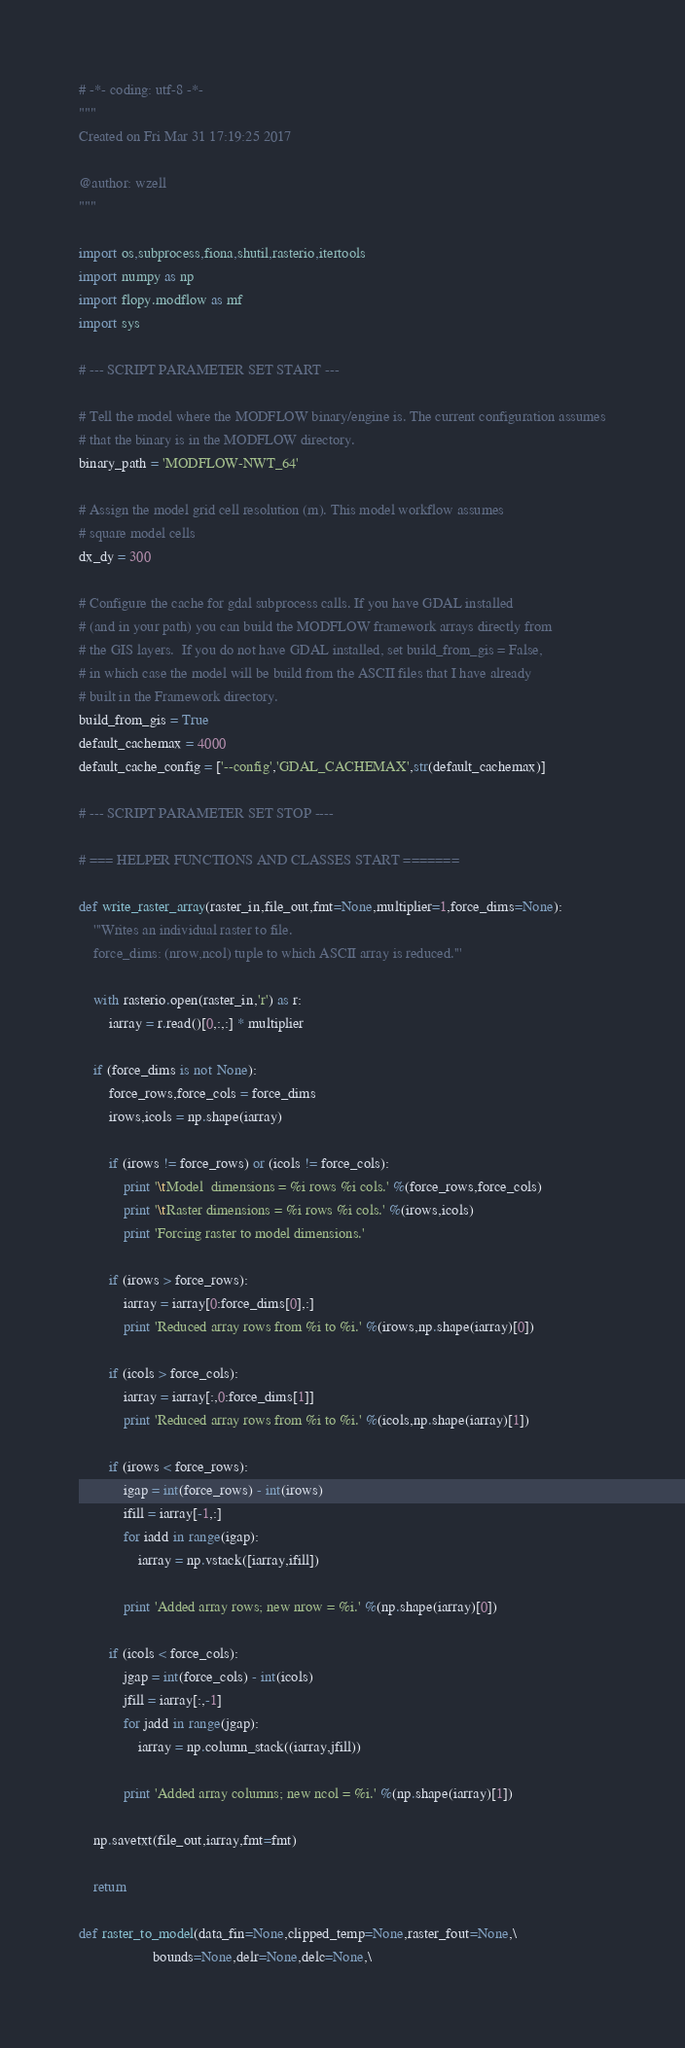Convert code to text. <code><loc_0><loc_0><loc_500><loc_500><_Python_># -*- coding: utf-8 -*-
"""
Created on Fri Mar 31 17:19:25 2017

@author: wzell
"""

import os,subprocess,fiona,shutil,rasterio,itertools
import numpy as np
import flopy.modflow as mf
import sys

# --- SCRIPT PARAMETER SET START ---

# Tell the model where the MODFLOW binary/engine is. The current configuration assumes
# that the binary is in the MODFLOW directory.
binary_path = 'MODFLOW-NWT_64'

# Assign the model grid cell resolution (m). This model workflow assumes
# square model cells
dx_dy = 300

# Configure the cache for gdal subprocess calls. If you have GDAL installed
# (and in your path) you can build the MODFLOW framework arrays directly from
# the GIS layers.  If you do not have GDAL installed, set build_from_gis = False,
# in which case the model will be build from the ASCII files that I have already
# built in the Framework directory.
build_from_gis = True
default_cachemax = 4000
default_cache_config = ['--config','GDAL_CACHEMAX',str(default_cachemax)]

# --- SCRIPT PARAMETER SET STOP ----

# === HELPER FUNCTIONS AND CLASSES START =======

def write_raster_array(raster_in,file_out,fmt=None,multiplier=1,force_dims=None):
    '''Writes an individual raster to file.
    force_dims: (nrow,ncol) tuple to which ASCII array is reduced.'''

    with rasterio.open(raster_in,'r') as r:
        iarray = r.read()[0,:,:] * multiplier

    if (force_dims is not None):
        force_rows,force_cols = force_dims
        irows,icols = np.shape(iarray)

        if (irows != force_rows) or (icols != force_cols):
            print '\tModel  dimensions = %i rows %i cols.' %(force_rows,force_cols)
            print '\tRaster dimensions = %i rows %i cols.' %(irows,icols)
            print 'Forcing raster to model dimensions.'

        if (irows > force_rows):
            iarray = iarray[0:force_dims[0],:]
            print 'Reduced array rows from %i to %i.' %(irows,np.shape(iarray)[0])

        if (icols > force_cols):
            iarray = iarray[:,0:force_dims[1]]
            print 'Reduced array rows from %i to %i.' %(icols,np.shape(iarray)[1])

        if (irows < force_rows):
            igap = int(force_rows) - int(irows)
            ifill = iarray[-1,:]
            for iadd in range(igap):
                iarray = np.vstack([iarray,ifill])

            print 'Added array rows; new nrow = %i.' %(np.shape(iarray)[0])

        if (icols < force_cols):
            jgap = int(force_cols) - int(icols)
            jfill = iarray[:,-1]
            for jadd in range(jgap):
                iarray = np.column_stack((iarray,jfill))

            print 'Added array columns; new ncol = %i.' %(np.shape(iarray)[1])

    np.savetxt(file_out,iarray,fmt=fmt)

    return

def raster_to_model(data_fin=None,clipped_temp=None,raster_fout=None,\
                    bounds=None,delr=None,delc=None,\</code> 